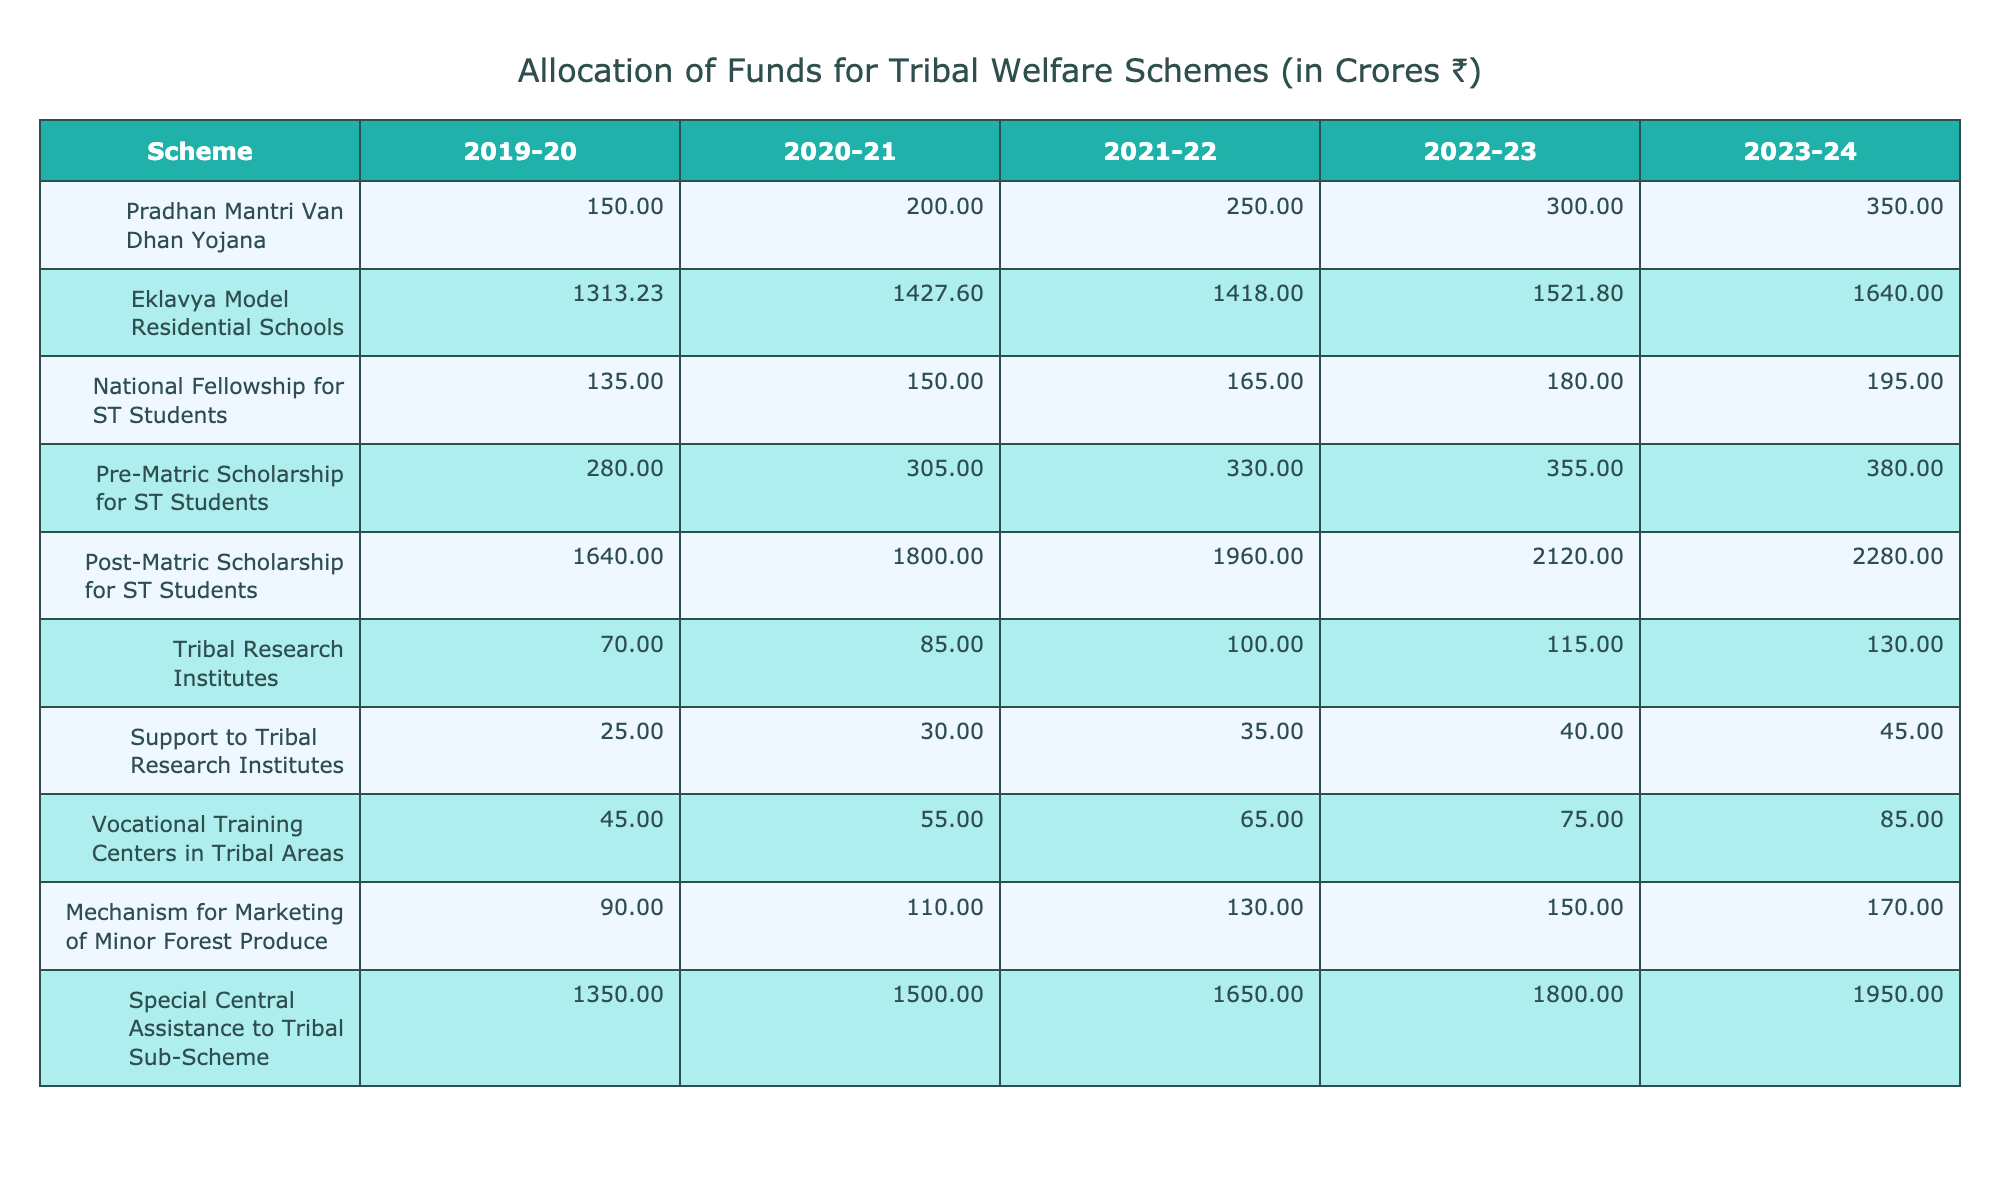What was the highest allocation for the Post-Matric Scholarship for ST Students in the last five years? The highest allocation for Post-Matric Scholarship for ST Students was in 2023-24, which was 2280.00 crores.
Answer: 2280.00 crores What was the total amount allocated to the Eklavya Model Residential Schools from 2019-20 to 2023-24? The total allocation is 1313.23 + 1427.60 + 1418.00 + 1521.80 + 1640.00 = 6320.63 crores.
Answer: 6320.63 crores Was there an increase in the funding for the Tribal Research Institutes every year? Comparing the values year by year shows that the allocation increased from 70.00 to 130.00 crores, indicating an increase every year; thus, the statement is true.
Answer: Yes In which year did the National Fellowship for ST Students experience the least increase in funding compared to the previous year? The increases were 15.00 (from 135.00 to 150.00), 15.00 (from 150.00 to 165.00), 15.00 (from 165.00 to 180.00), and 15.00 (from 180.00 to 195.00), showing uniform increases without any variation, so no specific year had the least increase.
Answer: All years had equal increase What is the average allocation for the Pradhan Mantri Van Dhan Yojana over the five years? The allocation values are 150.00, 200.00, 250.00, 300.00, and 350.00; summing these gives 1350.00, and dividing by 5 gives an average of 270.00 crores.
Answer: 270.00 crores What is the difference in allocations between the highest and lowest amount for the Special Central Assistance to Tribal Sub-Scheme? The highest allocation was 1950.00 in 2023-24 and the lowest was 1350.00 in 2019-20; the difference is 1950.00 - 1350.00 = 600.00 crores.
Answer: 600.00 crores Was the funding for Vocational Training Centers in Tribal Areas consistently below 100 crores over the past 5 years? The allocations were 45.00, 55.00, 65.00, 75.00, and 85.00, all below 100 crores, so the statement is true.
Answer: Yes How much more was spent on Post-Matric Scholarship for ST Students than on Pre-Matric Scholarship for ST Students in 2022-23? The Post-Matric amount was 2120.00 and the Pre-Matric amount was 355.00 in 2022-23; the difference is 2120.00 - 355.00 = 1765.00 crores.
Answer: 1765.00 crores What was the total allocation for all schemes combined in the fiscal year 2021-22? Summing all allocations: 250.00 + 1418.00 + 165.00 + 330.00 + 1960.00 + 100.00 + 35.00 + 65.00 + 130.00 + 1650.00 = 4123.00 crores.
Answer: 4123.00 crores What was the trend in funding for the mechanism for marketing minor forest produce from 2019-20 to 2023-24? The amounts increased steadily from 90.00 to 170.00 crores over the five years, indicating a consistent upward trend.
Answer: Consistent increase Which scheme received the second-highest allocation in the year 2022-23? The allocations for 2022-23 were as follows: Post-Matric (2120.00), Special Central Assistance (1800.00), Eklavya Schools (1521.80), making the second-highest allocation 1800.00 crores.
Answer: 1800.00 crores 